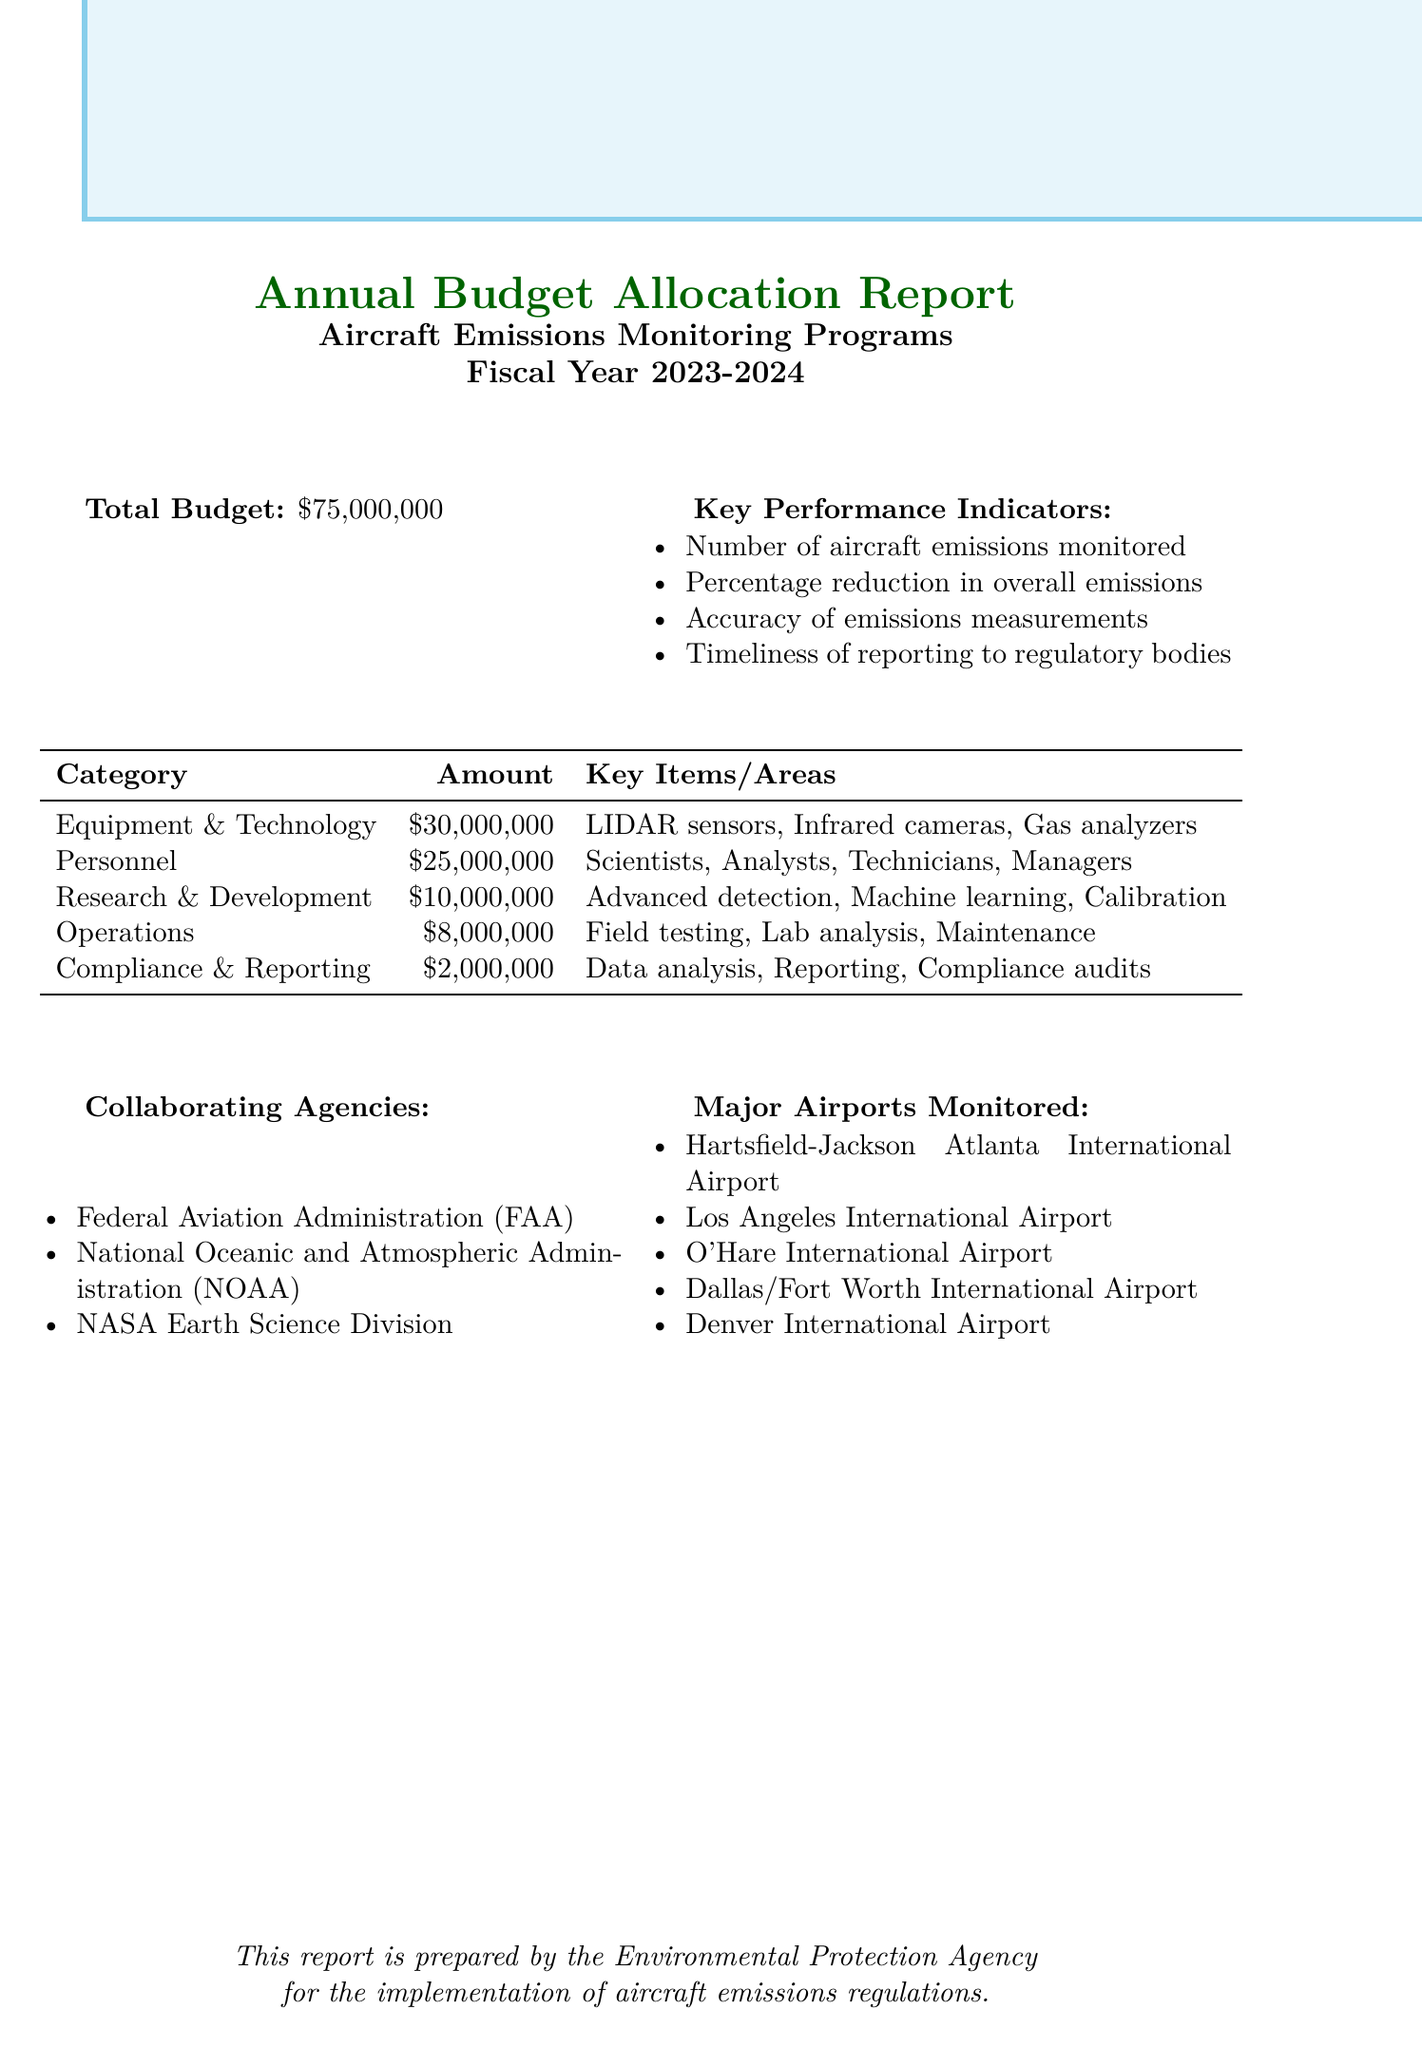what is the total budget? The total budget is clearly stated in the document as $75,000,000.
Answer: $75,000,000 how much is allocated for Equipment and Technology? The document specifies that the allocation for Equipment and Technology is $30,000,000.
Answer: $30,000,000 which agency collaborates with the EPA on this program? The document lists several collaborating agencies, including the Federal Aviation Administration (FAA).
Answer: Federal Aviation Administration (FAA) what are the key performance indicators listed? The document enumerates several key performance indicators, one of which is the Number of aircraft emissions monitored.
Answer: Number of aircraft emissions monitored how much budget is dedicated to Compliance and Reporting? The report states that $2,000,000 is allocated to Compliance and Reporting activities.
Answer: $2,000,000 what is the total amount allocated for Research and Development? The document specifies that the total allocated amount for Research and Development is $10,000,000.
Answer: $10,000,000 which major airport is included in the monitoring list? The report lists several major airports monitored, including Hartsfield-Jackson Atlanta International Airport.
Answer: Hartsfield-Jackson Atlanta International Airport how many categories are included in the budget breakdown? The document provides a breakdown into five categories for the budget allocation.
Answer: Five 